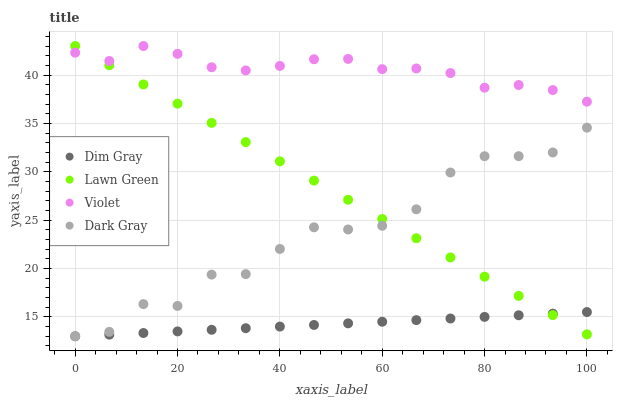Does Dim Gray have the minimum area under the curve?
Answer yes or no. Yes. Does Violet have the maximum area under the curve?
Answer yes or no. Yes. Does Lawn Green have the minimum area under the curve?
Answer yes or no. No. Does Lawn Green have the maximum area under the curve?
Answer yes or no. No. Is Dim Gray the smoothest?
Answer yes or no. Yes. Is Dark Gray the roughest?
Answer yes or no. Yes. Is Lawn Green the smoothest?
Answer yes or no. No. Is Lawn Green the roughest?
Answer yes or no. No. Does Dark Gray have the lowest value?
Answer yes or no. Yes. Does Lawn Green have the lowest value?
Answer yes or no. No. Does Violet have the highest value?
Answer yes or no. Yes. Does Dim Gray have the highest value?
Answer yes or no. No. Is Dark Gray less than Violet?
Answer yes or no. Yes. Is Violet greater than Dim Gray?
Answer yes or no. Yes. Does Violet intersect Lawn Green?
Answer yes or no. Yes. Is Violet less than Lawn Green?
Answer yes or no. No. Is Violet greater than Lawn Green?
Answer yes or no. No. Does Dark Gray intersect Violet?
Answer yes or no. No. 